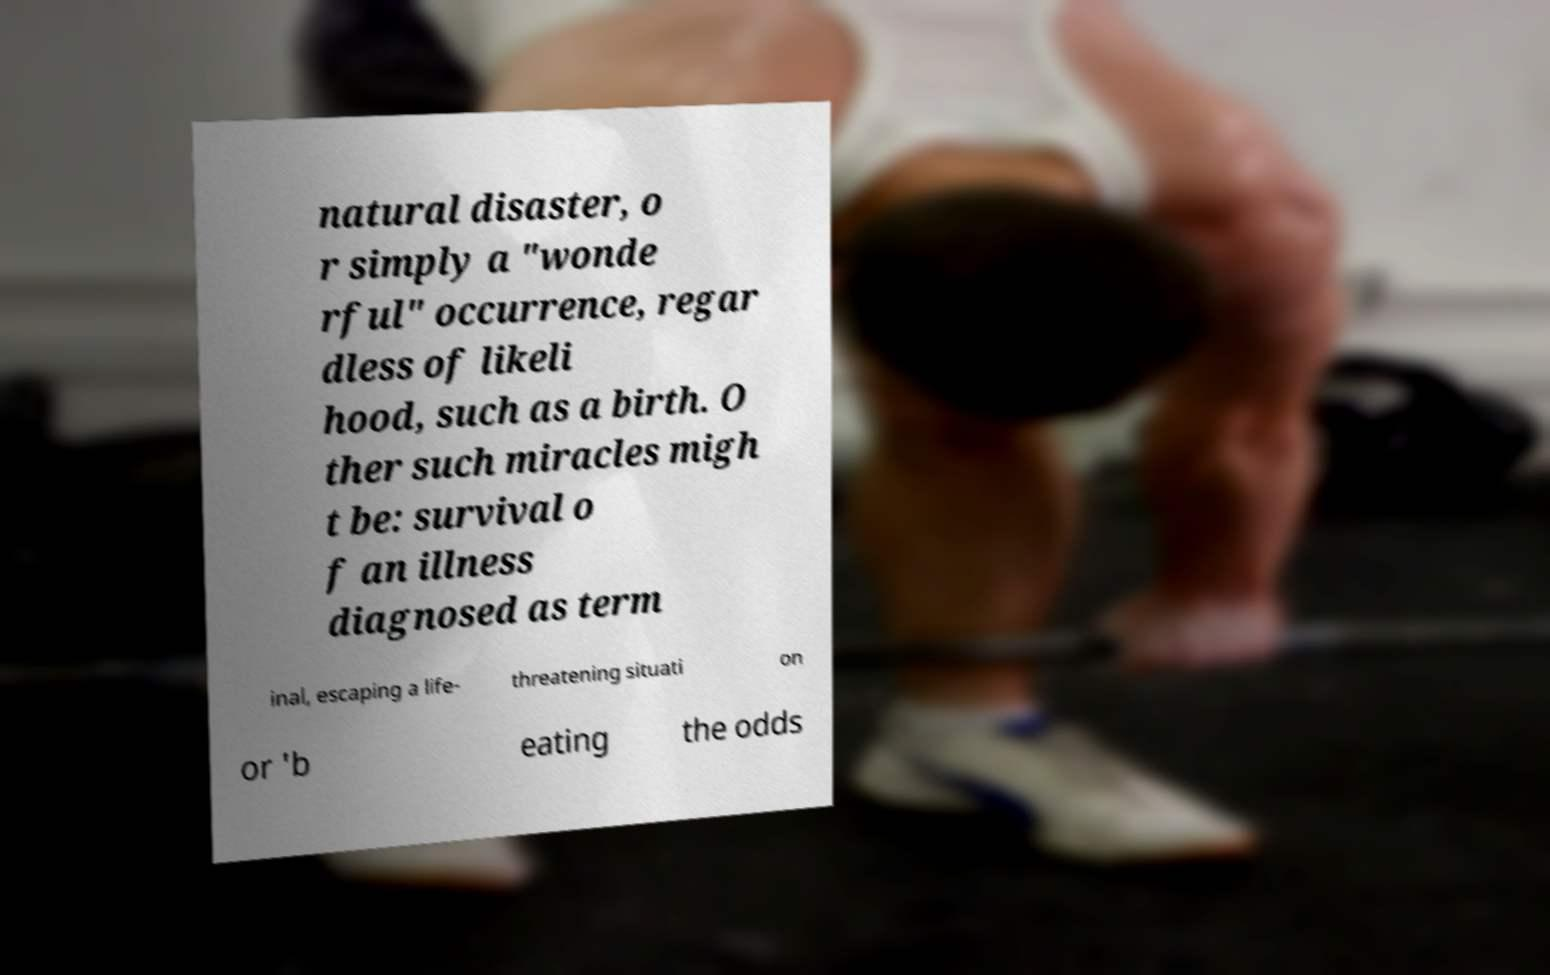Can you accurately transcribe the text from the provided image for me? natural disaster, o r simply a "wonde rful" occurrence, regar dless of likeli hood, such as a birth. O ther such miracles migh t be: survival o f an illness diagnosed as term inal, escaping a life- threatening situati on or 'b eating the odds 